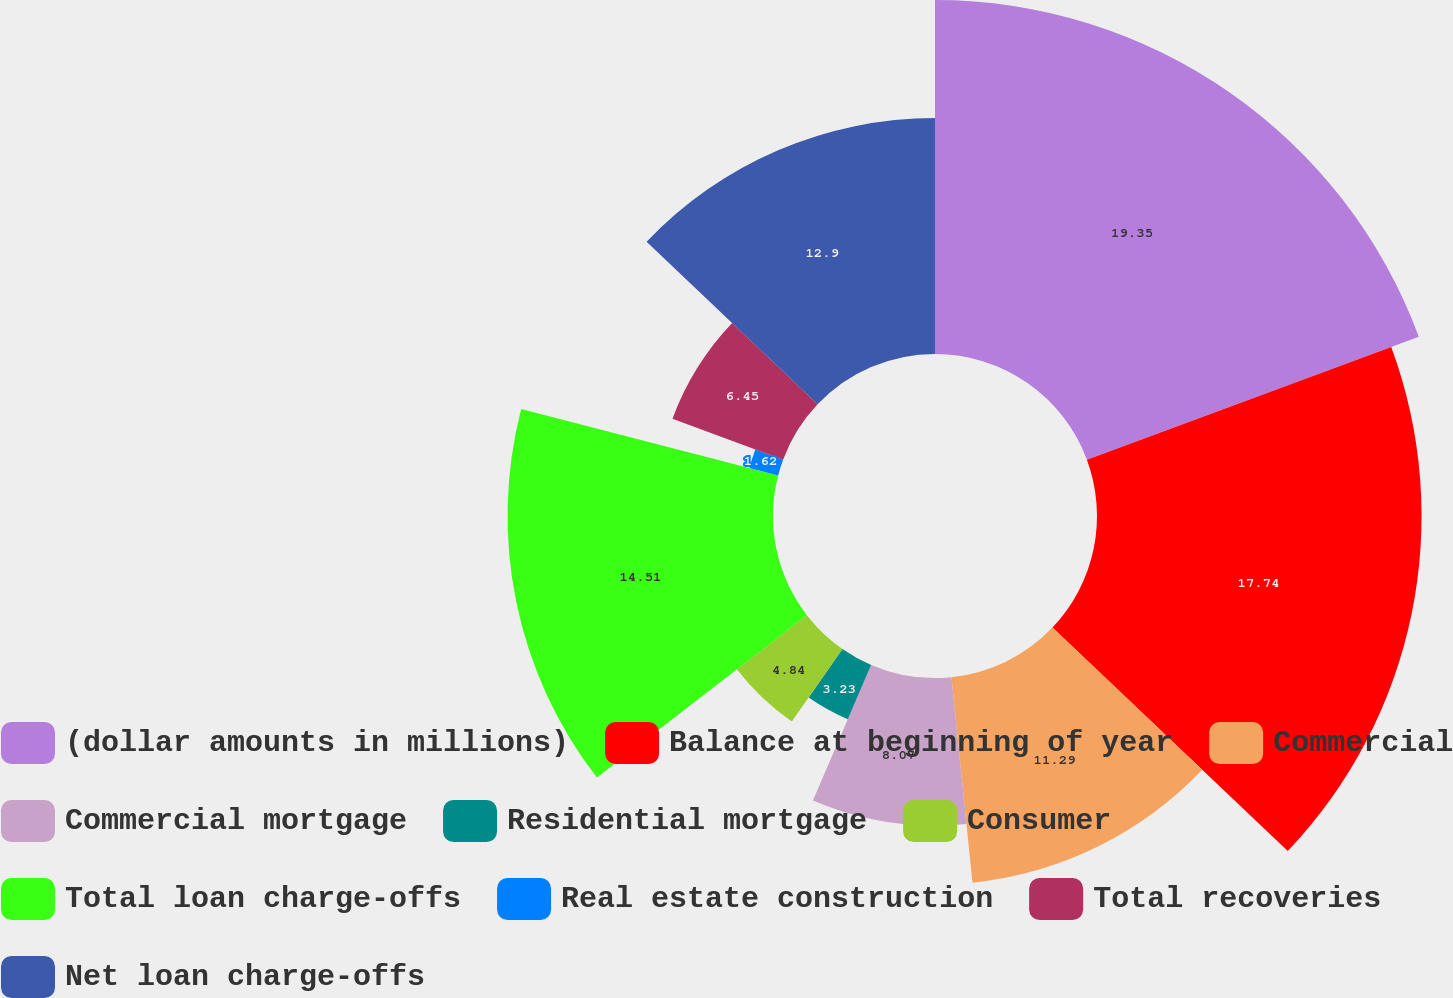Convert chart to OTSL. <chart><loc_0><loc_0><loc_500><loc_500><pie_chart><fcel>(dollar amounts in millions)<fcel>Balance at beginning of year<fcel>Commercial<fcel>Commercial mortgage<fcel>Residential mortgage<fcel>Consumer<fcel>Total loan charge-offs<fcel>Real estate construction<fcel>Total recoveries<fcel>Net loan charge-offs<nl><fcel>19.35%<fcel>17.74%<fcel>11.29%<fcel>8.07%<fcel>3.23%<fcel>4.84%<fcel>14.51%<fcel>1.62%<fcel>6.45%<fcel>12.9%<nl></chart> 